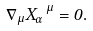<formula> <loc_0><loc_0><loc_500><loc_500>\nabla _ { \mu } X _ { \alpha } ^ { \ \mu } = 0 .</formula> 